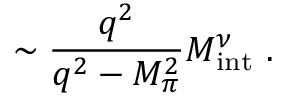Convert formula to latex. <formula><loc_0><loc_0><loc_500><loc_500>\sim \frac { q ^ { 2 } } { q ^ { 2 } - M _ { \pi } ^ { 2 } } M _ { i n t } ^ { \nu } .</formula> 